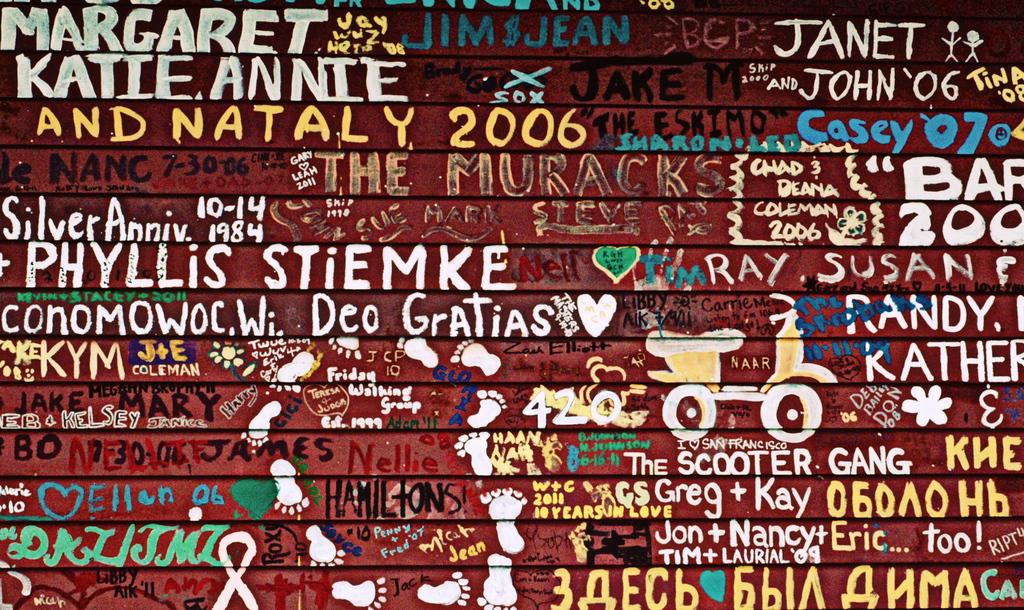What is the year after nataly?
Your answer should be compact. 2006. 